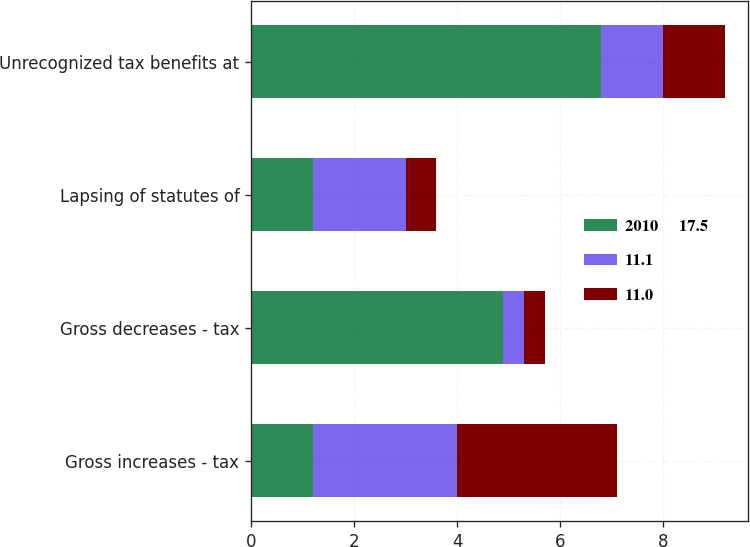Convert chart. <chart><loc_0><loc_0><loc_500><loc_500><stacked_bar_chart><ecel><fcel>Gross increases - tax<fcel>Gross decreases - tax<fcel>Lapsing of statutes of<fcel>Unrecognized tax benefits at<nl><fcel>2010     17.5<fcel>1.2<fcel>4.9<fcel>1.2<fcel>6.8<nl><fcel>11.1<fcel>2.8<fcel>0.4<fcel>1.8<fcel>1.2<nl><fcel>11.0<fcel>3.1<fcel>0.4<fcel>0.6<fcel>1.2<nl></chart> 